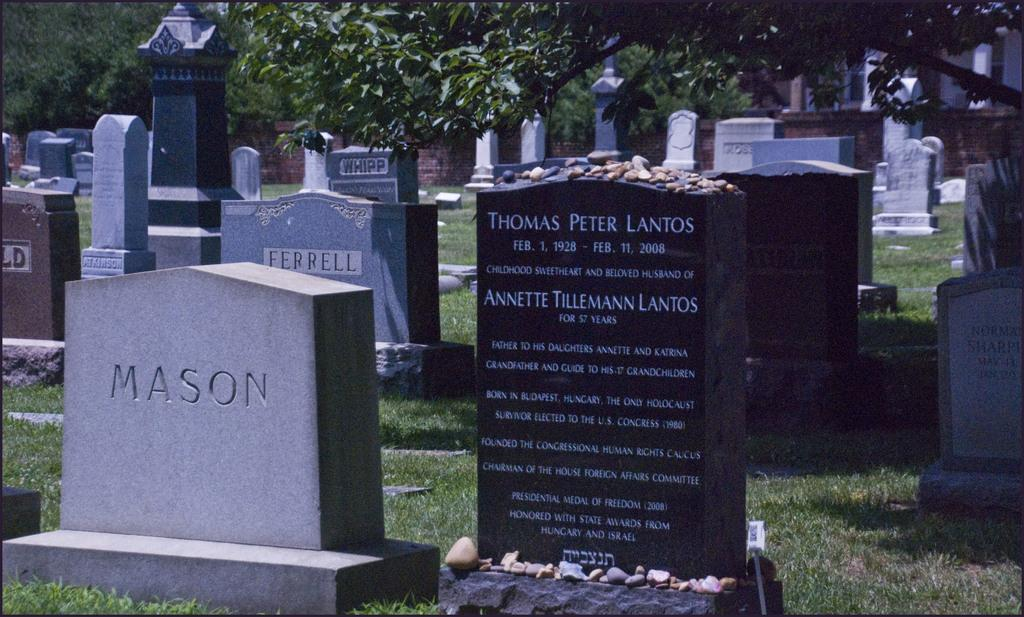What can be seen on the ground in the image? There are graves on the ground in the image. What type of vegetation covers the ground in the image? The ground is covered with grass. How many sugar cubes are placed on the graves in the image? There is no mention of sugar cubes in the image, so we cannot determine their presence or quantity. 